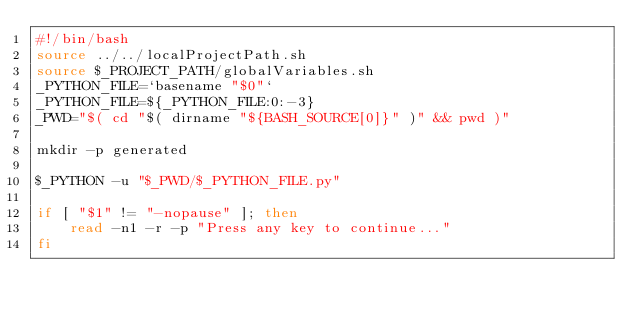<code> <loc_0><loc_0><loc_500><loc_500><_Bash_>#!/bin/bash
source ../../localProjectPath.sh
source $_PROJECT_PATH/globalVariables.sh
_PYTHON_FILE=`basename "$0"`
_PYTHON_FILE=${_PYTHON_FILE:0:-3}
_PWD="$( cd "$( dirname "${BASH_SOURCE[0]}" )" && pwd )"

mkdir -p generated

$_PYTHON -u "$_PWD/$_PYTHON_FILE.py"

if [ "$1" != "-nopause" ]; then
	read -n1 -r -p "Press any key to continue..."
fi
</code> 